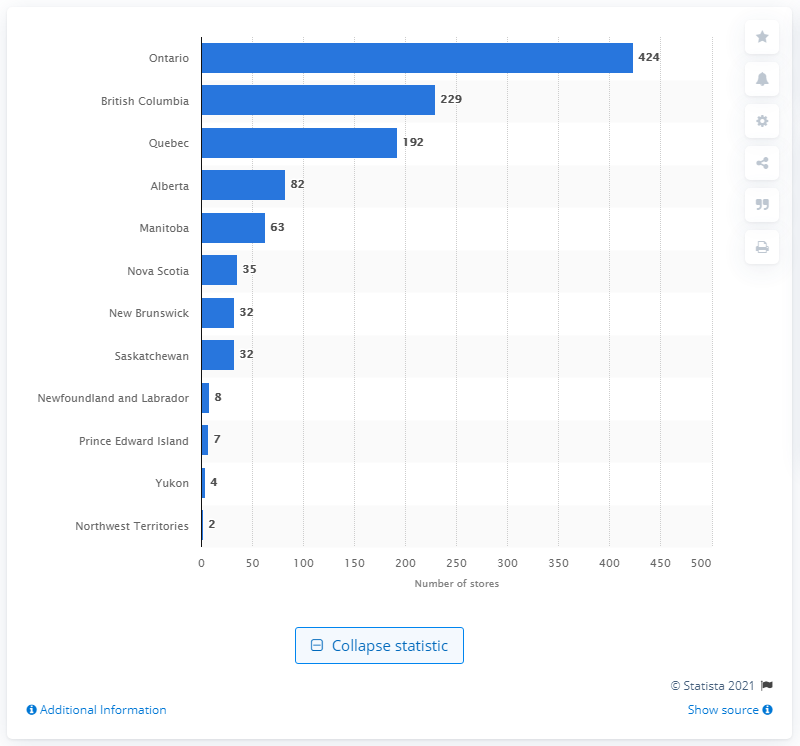Point out several critical features in this image. In 2020, there were 424 nursery stores and garden centers located in Ontario. 